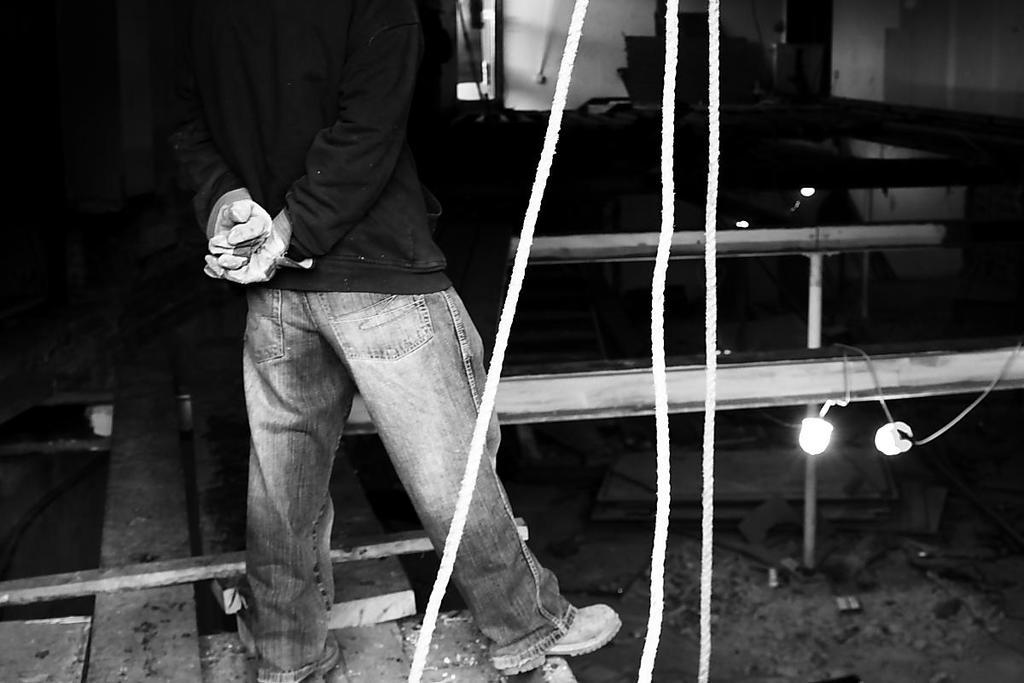What is the person in the image standing on? The person is standing on a wooden plank. What other objects can be seen in the image? There are ropes and lights attached to an iron railing in the image. What type of carriage is being pulled by the governor in the image? There is no carriage or governor present in the image. How does the person's death affect the scene in the image? There is no death or any indication of a person's demise in the image. 